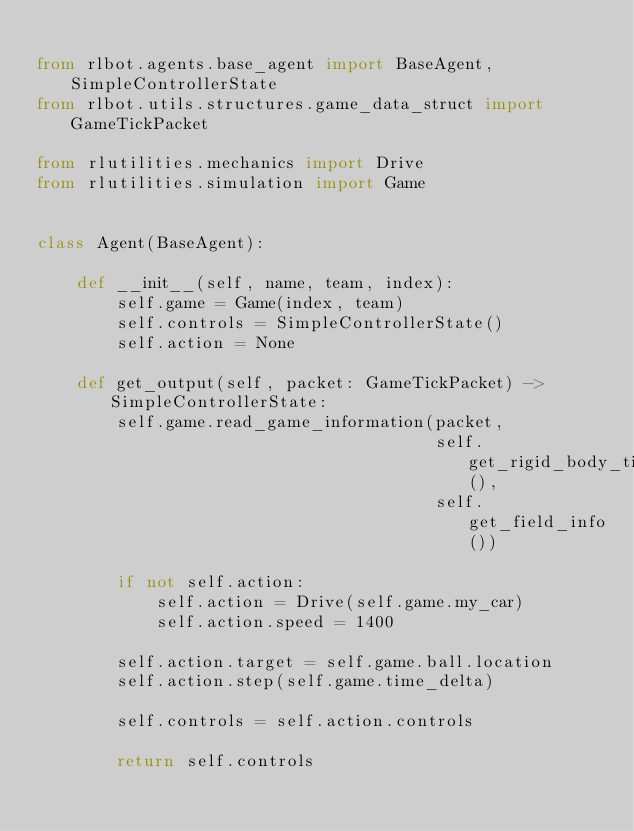<code> <loc_0><loc_0><loc_500><loc_500><_Python_>
from rlbot.agents.base_agent import BaseAgent, SimpleControllerState
from rlbot.utils.structures.game_data_struct import GameTickPacket

from rlutilities.mechanics import Drive
from rlutilities.simulation import Game


class Agent(BaseAgent):

    def __init__(self, name, team, index):
        self.game = Game(index, team)
        self.controls = SimpleControllerState()
        self.action = None

    def get_output(self, packet: GameTickPacket) -> SimpleControllerState:
        self.game.read_game_information(packet,
                                        self.get_rigid_body_tick(),
                                        self.get_field_info())

        if not self.action:
            self.action = Drive(self.game.my_car)
            self.action.speed = 1400

        self.action.target = self.game.ball.location
        self.action.step(self.game.time_delta)

        self.controls = self.action.controls

        return self.controls
</code> 